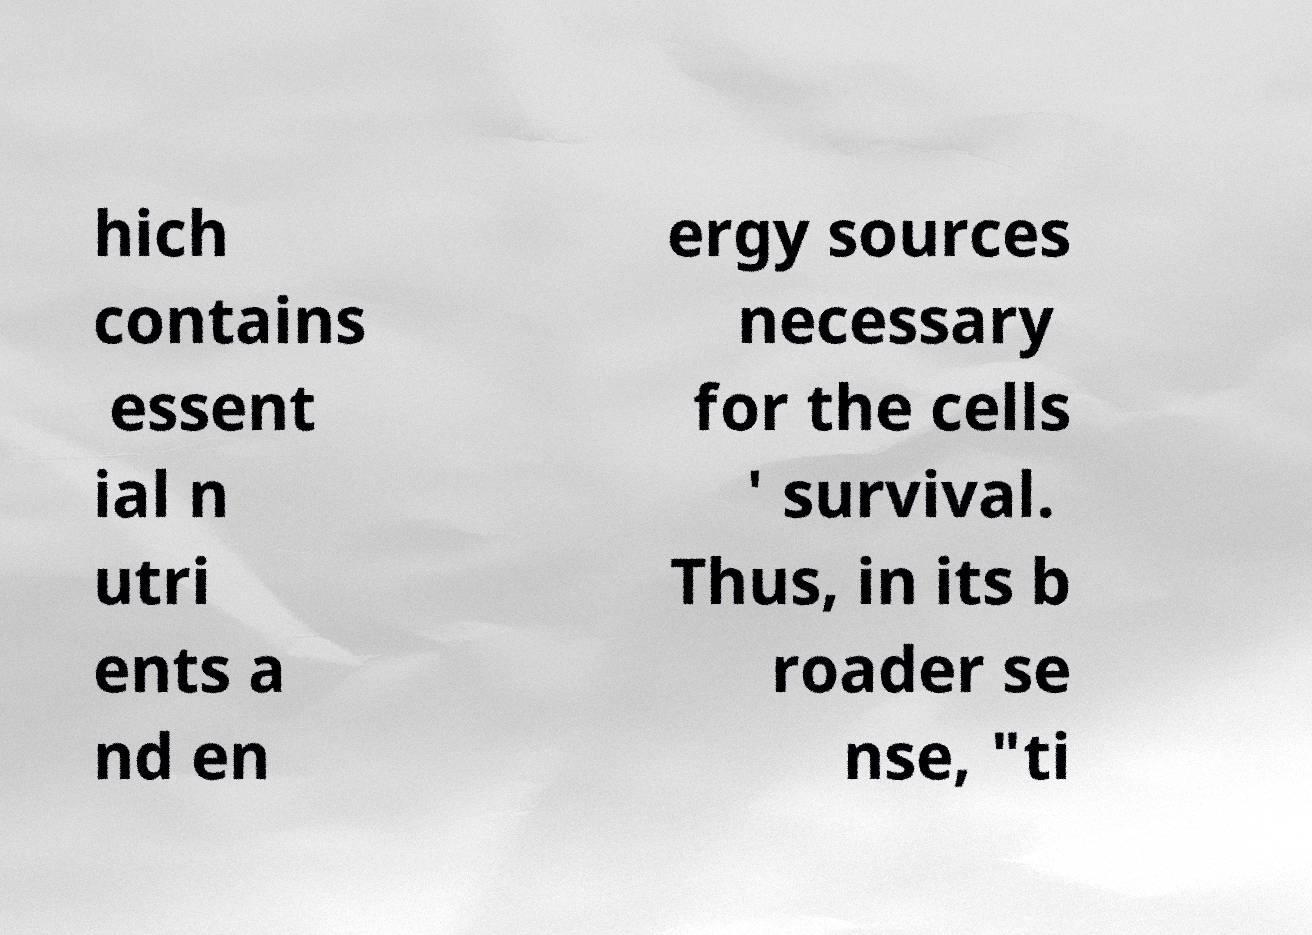For documentation purposes, I need the text within this image transcribed. Could you provide that? hich contains essent ial n utri ents a nd en ergy sources necessary for the cells ' survival. Thus, in its b roader se nse, "ti 